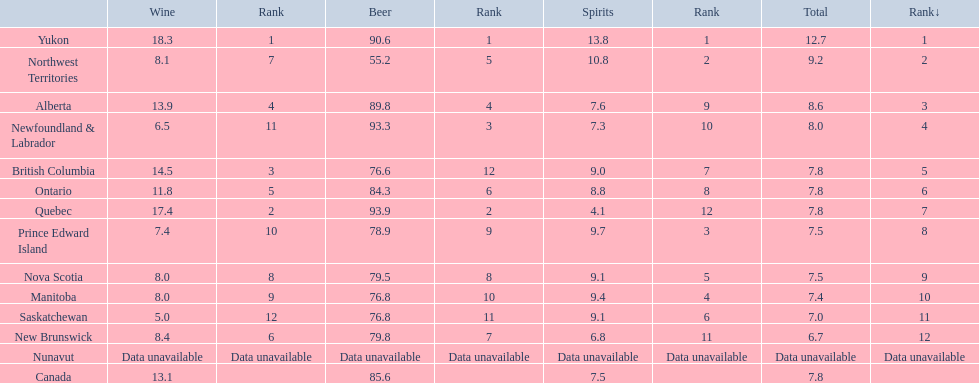In which location do individuals have the highest yearly average consumption of spirits? Yukon. What is the average number of liters consumed per person annually in this place? 12.7. 